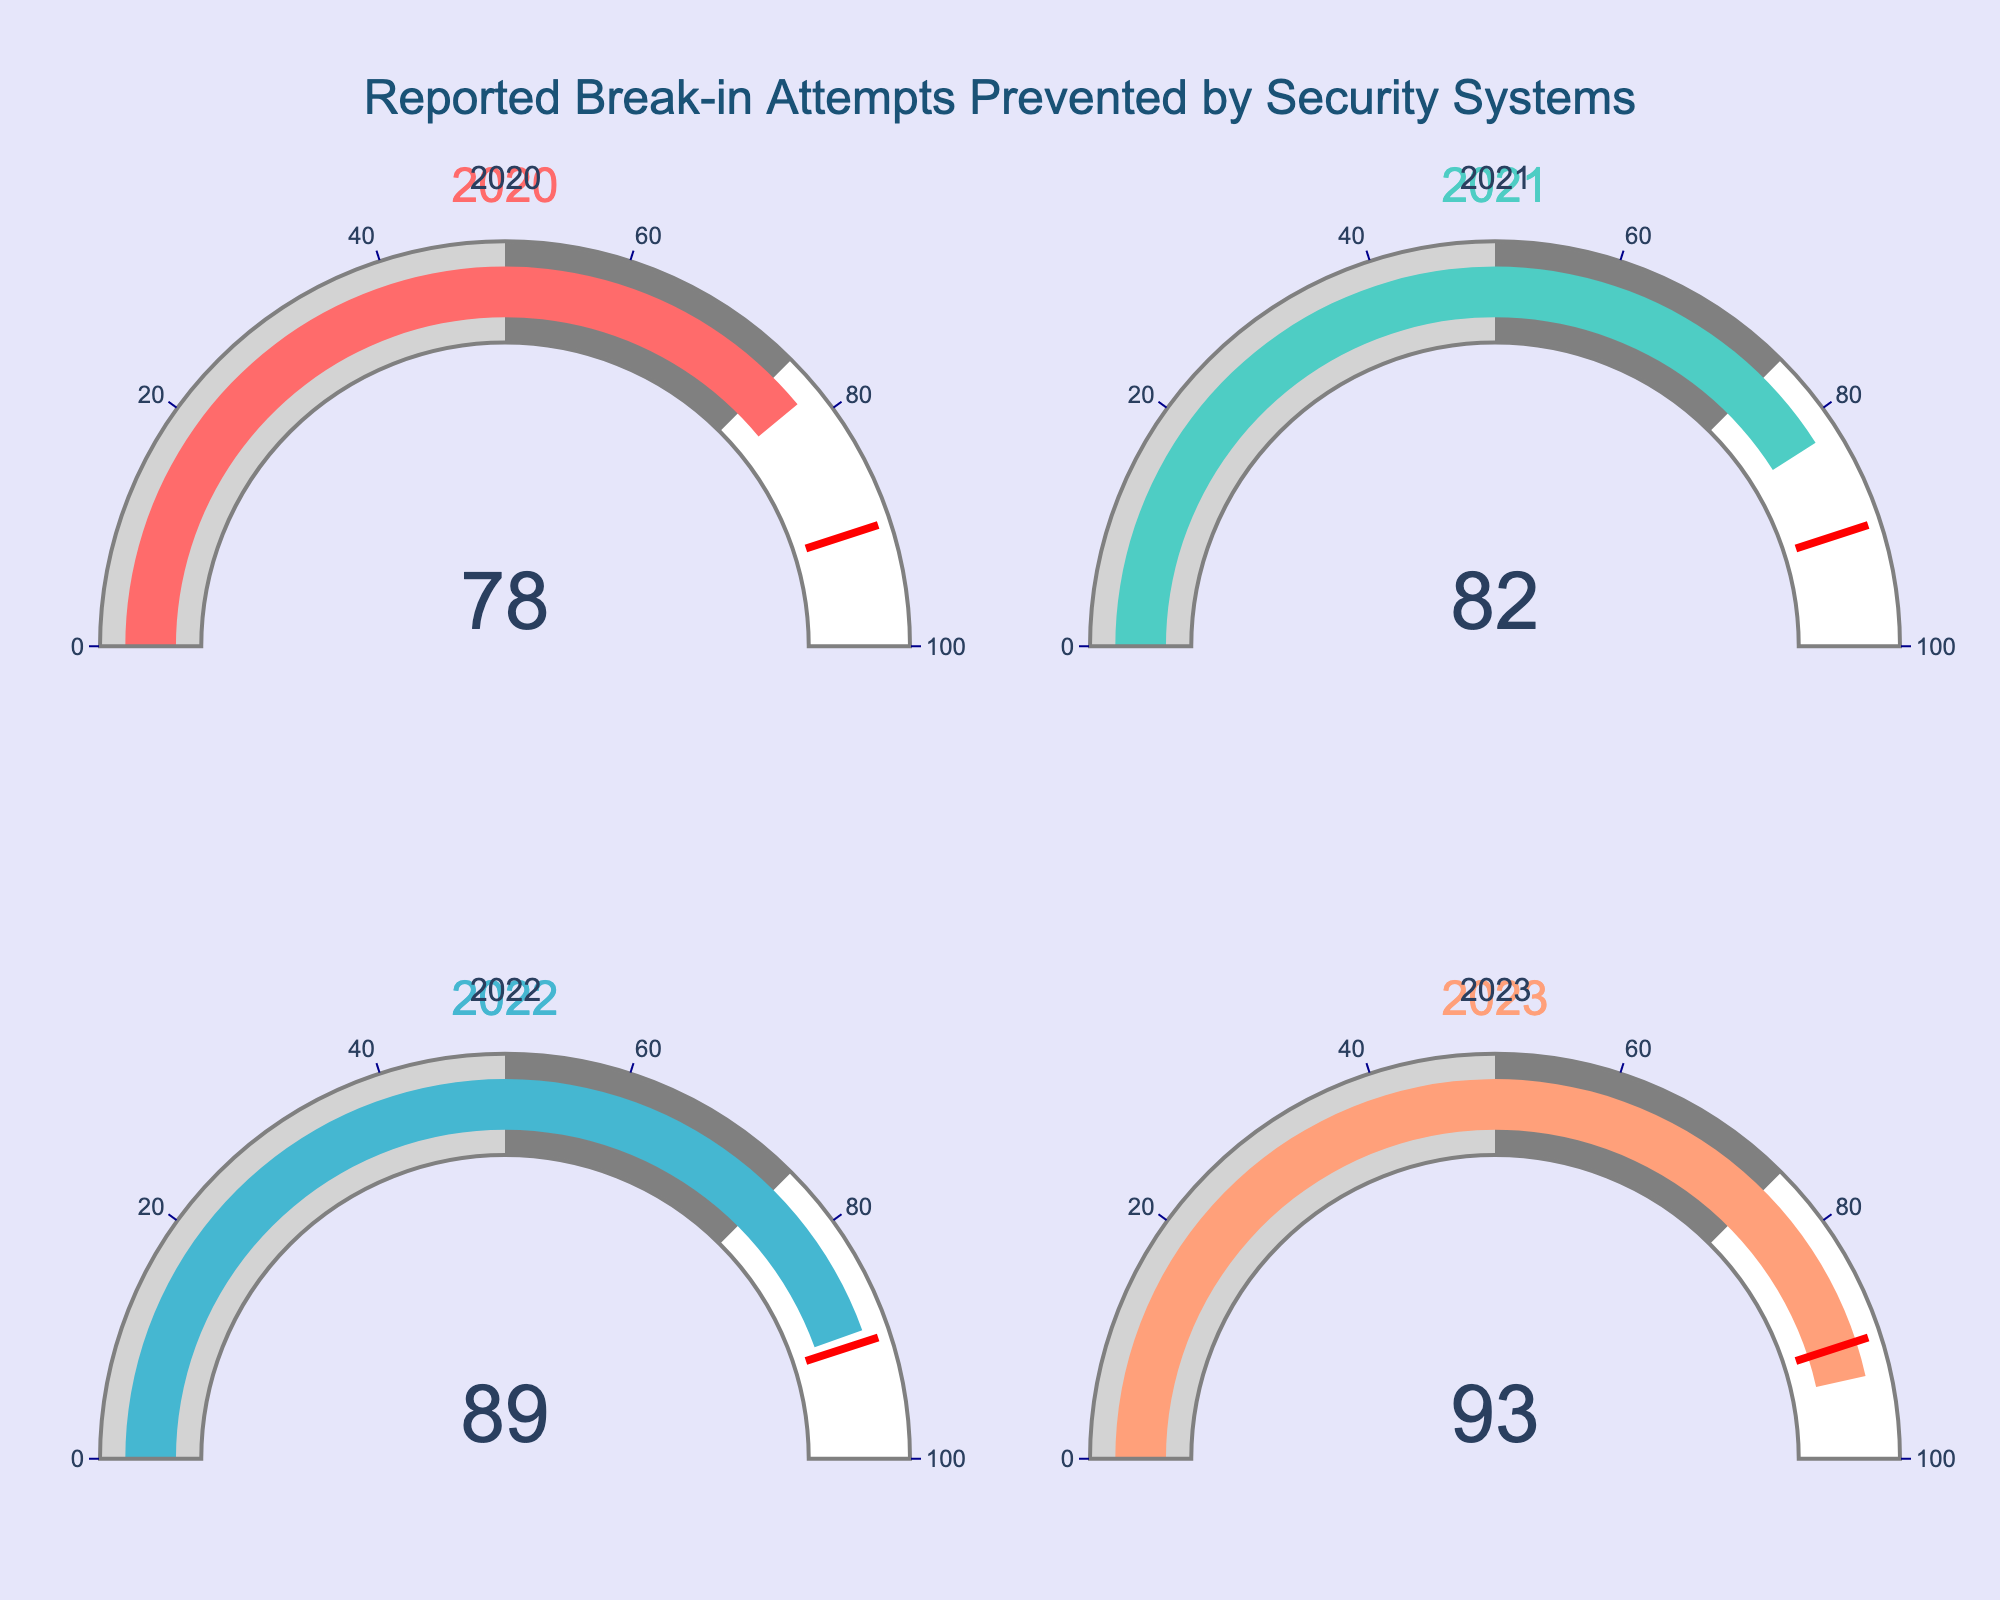what year had the highest number of prevented break-in attempts? By examining the gauge charts for each year, we can identify 2023 as the year with the highest number of prevented break-in attempts, which is 93.
Answer: 2023 Which year had the lowest number of prevented break-in attempts? By looking at the gauge charts, 2020 has the lowest number of prevented break-in attempts, which is 78.
Answer: 2020 What's the average number of prevented break-in attempts from 2020 to 2023? We add the numbers for each year: 78 (2020), 82 (2021), 89 (2022), and 93 (2023). The sum is 342. Dividing by 4, the average is 85.5.
Answer: 85.5 What is the increase in prevented break-in attempts from 2020 to 2023? Subtract the number of prevented break-ins in 2020 from the number in 2023: 93 - 78 = 15.
Answer: 15 Which year fell below the threshold value of 90 prevented break-ins? By looking at the threshold indicator on each gauge chart, only 2020 (78), 2021 (82), and 2022 (89) fall below the threshold of 90.
Answer: 2020, 2021, 2022 What is the total number of prevented break-in attempts over the displayed period? Sum the numbers for each year: 78 (2020), 82 (2021), 89 (2022), and 93 (2023). The total is 342.
Answer: 342 By how much did the number of prevented break-ins increase from 2021 to 2022? Subtract the number of prevented break-ins in 2021 from the number in 2022: 89 - 82 = 7.
Answer: 7 What is the trend in the number of prevented break-in attempts over the years? Observing the gauge charts, the number of prevented break-ins has been increasing steadily each year: 78 (2020), 82 (2021), 89 (2022), and 93 (2023).
Answer: Increasing How many years had preventive break-ins above the threshold of 50 but below 75? By examining the gauge charts, none of the years have preventive break-ins between 50 and 75.
Answer: 0 